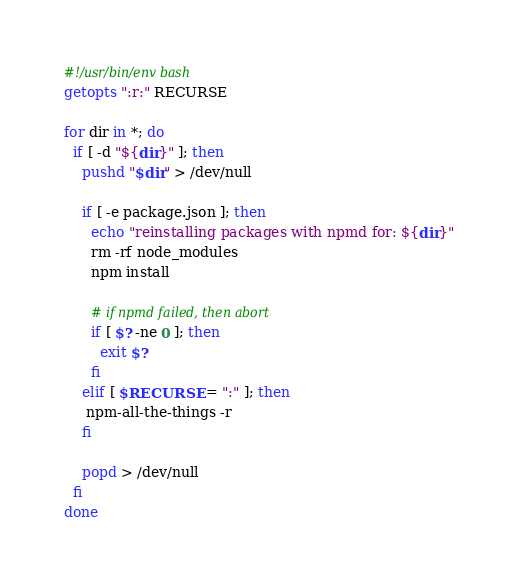Convert code to text. <code><loc_0><loc_0><loc_500><loc_500><_Bash_>#!/usr/bin/env bash
getopts ":r:" RECURSE

for dir in *; do
  if [ -d "${dir}" ]; then
    pushd "$dir" > /dev/null

    if [ -e package.json ]; then
      echo "reinstalling packages with npmd for: ${dir}"
      rm -rf node_modules
      npm install

      # if npmd failed, then abort
      if [ $? -ne 0 ]; then
        exit $?
      fi
    elif [ $RECURSE = ":" ]; then
     npm-all-the-things -r
    fi

    popd > /dev/null
  fi
done</code> 